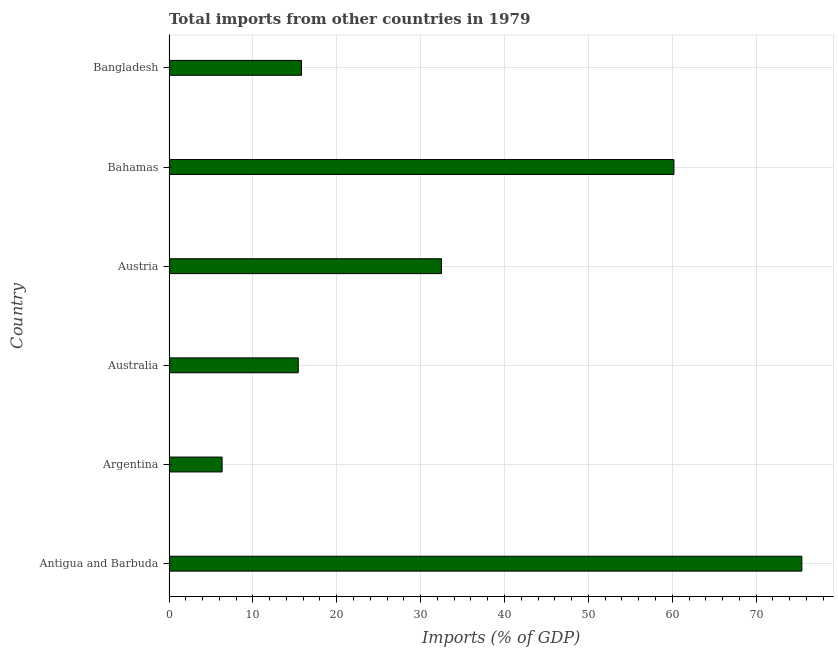Does the graph contain grids?
Give a very brief answer. Yes. What is the title of the graph?
Your answer should be compact. Total imports from other countries in 1979. What is the label or title of the X-axis?
Your answer should be compact. Imports (% of GDP). What is the total imports in Australia?
Your answer should be compact. 15.41. Across all countries, what is the maximum total imports?
Offer a terse response. 75.45. Across all countries, what is the minimum total imports?
Your response must be concise. 6.33. In which country was the total imports maximum?
Your answer should be very brief. Antigua and Barbuda. What is the sum of the total imports?
Offer a terse response. 205.69. What is the difference between the total imports in Australia and Bangladesh?
Offer a very short reply. -0.39. What is the average total imports per country?
Offer a very short reply. 34.28. What is the median total imports?
Provide a succinct answer. 24.14. What is the ratio of the total imports in Austria to that in Bangladesh?
Offer a terse response. 2.06. Is the total imports in Australia less than that in Bahamas?
Your answer should be compact. Yes. Is the difference between the total imports in Austria and Bangladesh greater than the difference between any two countries?
Provide a short and direct response. No. What is the difference between the highest and the second highest total imports?
Your answer should be very brief. 15.25. What is the difference between the highest and the lowest total imports?
Your answer should be very brief. 69.12. How many bars are there?
Keep it short and to the point. 6. How many countries are there in the graph?
Your answer should be compact. 6. What is the Imports (% of GDP) of Antigua and Barbuda?
Give a very brief answer. 75.45. What is the Imports (% of GDP) of Argentina?
Offer a terse response. 6.33. What is the Imports (% of GDP) of Australia?
Make the answer very short. 15.41. What is the Imports (% of GDP) in Austria?
Offer a very short reply. 32.49. What is the Imports (% of GDP) in Bahamas?
Offer a terse response. 60.2. What is the Imports (% of GDP) in Bangladesh?
Offer a very short reply. 15.8. What is the difference between the Imports (% of GDP) in Antigua and Barbuda and Argentina?
Give a very brief answer. 69.12. What is the difference between the Imports (% of GDP) in Antigua and Barbuda and Australia?
Make the answer very short. 60.04. What is the difference between the Imports (% of GDP) in Antigua and Barbuda and Austria?
Provide a short and direct response. 42.97. What is the difference between the Imports (% of GDP) in Antigua and Barbuda and Bahamas?
Provide a short and direct response. 15.25. What is the difference between the Imports (% of GDP) in Antigua and Barbuda and Bangladesh?
Give a very brief answer. 59.66. What is the difference between the Imports (% of GDP) in Argentina and Australia?
Provide a short and direct response. -9.08. What is the difference between the Imports (% of GDP) in Argentina and Austria?
Keep it short and to the point. -26.16. What is the difference between the Imports (% of GDP) in Argentina and Bahamas?
Provide a short and direct response. -53.87. What is the difference between the Imports (% of GDP) in Argentina and Bangladesh?
Give a very brief answer. -9.47. What is the difference between the Imports (% of GDP) in Australia and Austria?
Offer a very short reply. -17.07. What is the difference between the Imports (% of GDP) in Australia and Bahamas?
Provide a short and direct response. -44.79. What is the difference between the Imports (% of GDP) in Australia and Bangladesh?
Provide a short and direct response. -0.39. What is the difference between the Imports (% of GDP) in Austria and Bahamas?
Give a very brief answer. -27.72. What is the difference between the Imports (% of GDP) in Austria and Bangladesh?
Your answer should be very brief. 16.69. What is the difference between the Imports (% of GDP) in Bahamas and Bangladesh?
Keep it short and to the point. 44.41. What is the ratio of the Imports (% of GDP) in Antigua and Barbuda to that in Argentina?
Your response must be concise. 11.92. What is the ratio of the Imports (% of GDP) in Antigua and Barbuda to that in Australia?
Your answer should be compact. 4.9. What is the ratio of the Imports (% of GDP) in Antigua and Barbuda to that in Austria?
Keep it short and to the point. 2.32. What is the ratio of the Imports (% of GDP) in Antigua and Barbuda to that in Bahamas?
Make the answer very short. 1.25. What is the ratio of the Imports (% of GDP) in Antigua and Barbuda to that in Bangladesh?
Ensure brevity in your answer.  4.78. What is the ratio of the Imports (% of GDP) in Argentina to that in Australia?
Your answer should be very brief. 0.41. What is the ratio of the Imports (% of GDP) in Argentina to that in Austria?
Ensure brevity in your answer.  0.2. What is the ratio of the Imports (% of GDP) in Argentina to that in Bahamas?
Give a very brief answer. 0.1. What is the ratio of the Imports (% of GDP) in Argentina to that in Bangladesh?
Your response must be concise. 0.4. What is the ratio of the Imports (% of GDP) in Australia to that in Austria?
Keep it short and to the point. 0.47. What is the ratio of the Imports (% of GDP) in Australia to that in Bahamas?
Your response must be concise. 0.26. What is the ratio of the Imports (% of GDP) in Austria to that in Bahamas?
Keep it short and to the point. 0.54. What is the ratio of the Imports (% of GDP) in Austria to that in Bangladesh?
Keep it short and to the point. 2.06. What is the ratio of the Imports (% of GDP) in Bahamas to that in Bangladesh?
Offer a terse response. 3.81. 